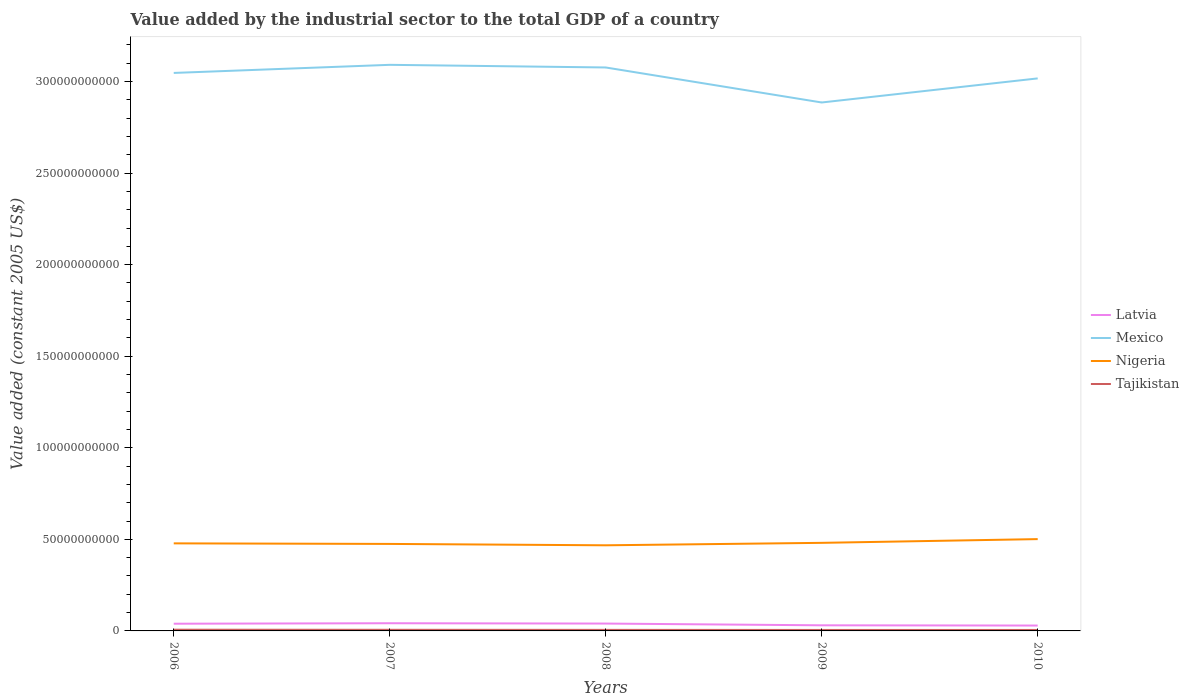Does the line corresponding to Latvia intersect with the line corresponding to Tajikistan?
Your answer should be very brief. No. Across all years, what is the maximum value added by the industrial sector in Mexico?
Your answer should be compact. 2.89e+11. What is the total value added by the industrial sector in Latvia in the graph?
Offer a terse response. 1.26e+08. What is the difference between the highest and the second highest value added by the industrial sector in Mexico?
Offer a terse response. 2.06e+1. Is the value added by the industrial sector in Nigeria strictly greater than the value added by the industrial sector in Mexico over the years?
Keep it short and to the point. Yes. How many years are there in the graph?
Ensure brevity in your answer.  5. Are the values on the major ticks of Y-axis written in scientific E-notation?
Give a very brief answer. No. Does the graph contain any zero values?
Ensure brevity in your answer.  No. Does the graph contain grids?
Make the answer very short. No. Where does the legend appear in the graph?
Your answer should be very brief. Center right. How many legend labels are there?
Give a very brief answer. 4. How are the legend labels stacked?
Your answer should be compact. Vertical. What is the title of the graph?
Your answer should be very brief. Value added by the industrial sector to the total GDP of a country. Does "Malta" appear as one of the legend labels in the graph?
Give a very brief answer. No. What is the label or title of the Y-axis?
Keep it short and to the point. Value added (constant 2005 US$). What is the Value added (constant 2005 US$) in Latvia in 2006?
Your response must be concise. 3.93e+09. What is the Value added (constant 2005 US$) in Mexico in 2006?
Provide a short and direct response. 3.05e+11. What is the Value added (constant 2005 US$) of Nigeria in 2006?
Provide a succinct answer. 4.78e+1. What is the Value added (constant 2005 US$) in Tajikistan in 2006?
Ensure brevity in your answer.  6.67e+08. What is the Value added (constant 2005 US$) of Latvia in 2007?
Ensure brevity in your answer.  4.20e+09. What is the Value added (constant 2005 US$) of Mexico in 2007?
Offer a terse response. 3.09e+11. What is the Value added (constant 2005 US$) in Nigeria in 2007?
Make the answer very short. 4.75e+1. What is the Value added (constant 2005 US$) in Tajikistan in 2007?
Offer a very short reply. 6.16e+08. What is the Value added (constant 2005 US$) of Latvia in 2008?
Your answer should be compact. 4.01e+09. What is the Value added (constant 2005 US$) of Mexico in 2008?
Offer a terse response. 3.08e+11. What is the Value added (constant 2005 US$) of Nigeria in 2008?
Your answer should be compact. 4.68e+1. What is the Value added (constant 2005 US$) of Tajikistan in 2008?
Your answer should be very brief. 5.72e+08. What is the Value added (constant 2005 US$) in Latvia in 2009?
Ensure brevity in your answer.  3.06e+09. What is the Value added (constant 2005 US$) of Mexico in 2009?
Offer a terse response. 2.89e+11. What is the Value added (constant 2005 US$) in Nigeria in 2009?
Make the answer very short. 4.81e+1. What is the Value added (constant 2005 US$) in Tajikistan in 2009?
Make the answer very short. 5.31e+08. What is the Value added (constant 2005 US$) in Latvia in 2010?
Make the answer very short. 2.94e+09. What is the Value added (constant 2005 US$) of Mexico in 2010?
Offer a very short reply. 3.02e+11. What is the Value added (constant 2005 US$) of Nigeria in 2010?
Give a very brief answer. 5.01e+1. What is the Value added (constant 2005 US$) of Tajikistan in 2010?
Offer a terse response. 5.19e+08. Across all years, what is the maximum Value added (constant 2005 US$) in Latvia?
Make the answer very short. 4.20e+09. Across all years, what is the maximum Value added (constant 2005 US$) of Mexico?
Provide a succinct answer. 3.09e+11. Across all years, what is the maximum Value added (constant 2005 US$) in Nigeria?
Your answer should be very brief. 5.01e+1. Across all years, what is the maximum Value added (constant 2005 US$) in Tajikistan?
Your response must be concise. 6.67e+08. Across all years, what is the minimum Value added (constant 2005 US$) in Latvia?
Offer a terse response. 2.94e+09. Across all years, what is the minimum Value added (constant 2005 US$) in Mexico?
Your answer should be very brief. 2.89e+11. Across all years, what is the minimum Value added (constant 2005 US$) of Nigeria?
Your answer should be compact. 4.68e+1. Across all years, what is the minimum Value added (constant 2005 US$) in Tajikistan?
Give a very brief answer. 5.19e+08. What is the total Value added (constant 2005 US$) in Latvia in the graph?
Ensure brevity in your answer.  1.81e+1. What is the total Value added (constant 2005 US$) of Mexico in the graph?
Provide a succinct answer. 1.51e+12. What is the total Value added (constant 2005 US$) in Nigeria in the graph?
Ensure brevity in your answer.  2.40e+11. What is the total Value added (constant 2005 US$) in Tajikistan in the graph?
Provide a short and direct response. 2.91e+09. What is the difference between the Value added (constant 2005 US$) in Latvia in 2006 and that in 2007?
Give a very brief answer. -2.67e+08. What is the difference between the Value added (constant 2005 US$) of Mexico in 2006 and that in 2007?
Make the answer very short. -4.43e+09. What is the difference between the Value added (constant 2005 US$) in Nigeria in 2006 and that in 2007?
Ensure brevity in your answer.  3.00e+08. What is the difference between the Value added (constant 2005 US$) in Tajikistan in 2006 and that in 2007?
Offer a very short reply. 5.12e+07. What is the difference between the Value added (constant 2005 US$) of Latvia in 2006 and that in 2008?
Your response must be concise. -8.38e+07. What is the difference between the Value added (constant 2005 US$) of Mexico in 2006 and that in 2008?
Make the answer very short. -2.99e+09. What is the difference between the Value added (constant 2005 US$) in Nigeria in 2006 and that in 2008?
Offer a terse response. 1.05e+09. What is the difference between the Value added (constant 2005 US$) in Tajikistan in 2006 and that in 2008?
Give a very brief answer. 9.50e+07. What is the difference between the Value added (constant 2005 US$) of Latvia in 2006 and that in 2009?
Provide a short and direct response. 8.66e+08. What is the difference between the Value added (constant 2005 US$) in Mexico in 2006 and that in 2009?
Provide a short and direct response. 1.61e+1. What is the difference between the Value added (constant 2005 US$) in Nigeria in 2006 and that in 2009?
Your response must be concise. -2.82e+08. What is the difference between the Value added (constant 2005 US$) in Tajikistan in 2006 and that in 2009?
Provide a short and direct response. 1.36e+08. What is the difference between the Value added (constant 2005 US$) in Latvia in 2006 and that in 2010?
Keep it short and to the point. 9.92e+08. What is the difference between the Value added (constant 2005 US$) in Mexico in 2006 and that in 2010?
Your answer should be very brief. 2.98e+09. What is the difference between the Value added (constant 2005 US$) of Nigeria in 2006 and that in 2010?
Ensure brevity in your answer.  -2.32e+09. What is the difference between the Value added (constant 2005 US$) of Tajikistan in 2006 and that in 2010?
Provide a short and direct response. 1.48e+08. What is the difference between the Value added (constant 2005 US$) in Latvia in 2007 and that in 2008?
Offer a very short reply. 1.83e+08. What is the difference between the Value added (constant 2005 US$) in Mexico in 2007 and that in 2008?
Your answer should be very brief. 1.44e+09. What is the difference between the Value added (constant 2005 US$) of Nigeria in 2007 and that in 2008?
Keep it short and to the point. 7.52e+08. What is the difference between the Value added (constant 2005 US$) of Tajikistan in 2007 and that in 2008?
Offer a terse response. 4.39e+07. What is the difference between the Value added (constant 2005 US$) of Latvia in 2007 and that in 2009?
Your answer should be compact. 1.13e+09. What is the difference between the Value added (constant 2005 US$) of Mexico in 2007 and that in 2009?
Offer a very short reply. 2.06e+1. What is the difference between the Value added (constant 2005 US$) of Nigeria in 2007 and that in 2009?
Provide a succinct answer. -5.82e+08. What is the difference between the Value added (constant 2005 US$) in Tajikistan in 2007 and that in 2009?
Your answer should be compact. 8.45e+07. What is the difference between the Value added (constant 2005 US$) in Latvia in 2007 and that in 2010?
Provide a succinct answer. 1.26e+09. What is the difference between the Value added (constant 2005 US$) of Mexico in 2007 and that in 2010?
Offer a terse response. 7.41e+09. What is the difference between the Value added (constant 2005 US$) in Nigeria in 2007 and that in 2010?
Offer a very short reply. -2.62e+09. What is the difference between the Value added (constant 2005 US$) of Tajikistan in 2007 and that in 2010?
Make the answer very short. 9.73e+07. What is the difference between the Value added (constant 2005 US$) of Latvia in 2008 and that in 2009?
Offer a terse response. 9.50e+08. What is the difference between the Value added (constant 2005 US$) of Mexico in 2008 and that in 2009?
Offer a very short reply. 1.91e+1. What is the difference between the Value added (constant 2005 US$) in Nigeria in 2008 and that in 2009?
Your response must be concise. -1.33e+09. What is the difference between the Value added (constant 2005 US$) in Tajikistan in 2008 and that in 2009?
Provide a short and direct response. 4.07e+07. What is the difference between the Value added (constant 2005 US$) of Latvia in 2008 and that in 2010?
Ensure brevity in your answer.  1.08e+09. What is the difference between the Value added (constant 2005 US$) of Mexico in 2008 and that in 2010?
Your response must be concise. 5.96e+09. What is the difference between the Value added (constant 2005 US$) of Nigeria in 2008 and that in 2010?
Ensure brevity in your answer.  -3.37e+09. What is the difference between the Value added (constant 2005 US$) in Tajikistan in 2008 and that in 2010?
Make the answer very short. 5.35e+07. What is the difference between the Value added (constant 2005 US$) in Latvia in 2009 and that in 2010?
Offer a very short reply. 1.26e+08. What is the difference between the Value added (constant 2005 US$) of Mexico in 2009 and that in 2010?
Offer a terse response. -1.32e+1. What is the difference between the Value added (constant 2005 US$) in Nigeria in 2009 and that in 2010?
Offer a very short reply. -2.04e+09. What is the difference between the Value added (constant 2005 US$) in Tajikistan in 2009 and that in 2010?
Provide a short and direct response. 1.28e+07. What is the difference between the Value added (constant 2005 US$) of Latvia in 2006 and the Value added (constant 2005 US$) of Mexico in 2007?
Provide a short and direct response. -3.05e+11. What is the difference between the Value added (constant 2005 US$) in Latvia in 2006 and the Value added (constant 2005 US$) in Nigeria in 2007?
Offer a terse response. -4.36e+1. What is the difference between the Value added (constant 2005 US$) in Latvia in 2006 and the Value added (constant 2005 US$) in Tajikistan in 2007?
Keep it short and to the point. 3.31e+09. What is the difference between the Value added (constant 2005 US$) in Mexico in 2006 and the Value added (constant 2005 US$) in Nigeria in 2007?
Provide a short and direct response. 2.57e+11. What is the difference between the Value added (constant 2005 US$) of Mexico in 2006 and the Value added (constant 2005 US$) of Tajikistan in 2007?
Your response must be concise. 3.04e+11. What is the difference between the Value added (constant 2005 US$) of Nigeria in 2006 and the Value added (constant 2005 US$) of Tajikistan in 2007?
Offer a terse response. 4.72e+1. What is the difference between the Value added (constant 2005 US$) of Latvia in 2006 and the Value added (constant 2005 US$) of Mexico in 2008?
Keep it short and to the point. -3.04e+11. What is the difference between the Value added (constant 2005 US$) in Latvia in 2006 and the Value added (constant 2005 US$) in Nigeria in 2008?
Make the answer very short. -4.28e+1. What is the difference between the Value added (constant 2005 US$) of Latvia in 2006 and the Value added (constant 2005 US$) of Tajikistan in 2008?
Make the answer very short. 3.36e+09. What is the difference between the Value added (constant 2005 US$) in Mexico in 2006 and the Value added (constant 2005 US$) in Nigeria in 2008?
Make the answer very short. 2.58e+11. What is the difference between the Value added (constant 2005 US$) of Mexico in 2006 and the Value added (constant 2005 US$) of Tajikistan in 2008?
Provide a short and direct response. 3.04e+11. What is the difference between the Value added (constant 2005 US$) in Nigeria in 2006 and the Value added (constant 2005 US$) in Tajikistan in 2008?
Ensure brevity in your answer.  4.72e+1. What is the difference between the Value added (constant 2005 US$) of Latvia in 2006 and the Value added (constant 2005 US$) of Mexico in 2009?
Provide a succinct answer. -2.85e+11. What is the difference between the Value added (constant 2005 US$) of Latvia in 2006 and the Value added (constant 2005 US$) of Nigeria in 2009?
Your answer should be very brief. -4.42e+1. What is the difference between the Value added (constant 2005 US$) of Latvia in 2006 and the Value added (constant 2005 US$) of Tajikistan in 2009?
Make the answer very short. 3.40e+09. What is the difference between the Value added (constant 2005 US$) in Mexico in 2006 and the Value added (constant 2005 US$) in Nigeria in 2009?
Your response must be concise. 2.57e+11. What is the difference between the Value added (constant 2005 US$) of Mexico in 2006 and the Value added (constant 2005 US$) of Tajikistan in 2009?
Offer a very short reply. 3.04e+11. What is the difference between the Value added (constant 2005 US$) in Nigeria in 2006 and the Value added (constant 2005 US$) in Tajikistan in 2009?
Your answer should be compact. 4.73e+1. What is the difference between the Value added (constant 2005 US$) of Latvia in 2006 and the Value added (constant 2005 US$) of Mexico in 2010?
Offer a terse response. -2.98e+11. What is the difference between the Value added (constant 2005 US$) of Latvia in 2006 and the Value added (constant 2005 US$) of Nigeria in 2010?
Make the answer very short. -4.62e+1. What is the difference between the Value added (constant 2005 US$) of Latvia in 2006 and the Value added (constant 2005 US$) of Tajikistan in 2010?
Offer a terse response. 3.41e+09. What is the difference between the Value added (constant 2005 US$) in Mexico in 2006 and the Value added (constant 2005 US$) in Nigeria in 2010?
Give a very brief answer. 2.55e+11. What is the difference between the Value added (constant 2005 US$) of Mexico in 2006 and the Value added (constant 2005 US$) of Tajikistan in 2010?
Provide a succinct answer. 3.04e+11. What is the difference between the Value added (constant 2005 US$) in Nigeria in 2006 and the Value added (constant 2005 US$) in Tajikistan in 2010?
Offer a terse response. 4.73e+1. What is the difference between the Value added (constant 2005 US$) in Latvia in 2007 and the Value added (constant 2005 US$) in Mexico in 2008?
Offer a very short reply. -3.03e+11. What is the difference between the Value added (constant 2005 US$) of Latvia in 2007 and the Value added (constant 2005 US$) of Nigeria in 2008?
Your answer should be very brief. -4.26e+1. What is the difference between the Value added (constant 2005 US$) in Latvia in 2007 and the Value added (constant 2005 US$) in Tajikistan in 2008?
Make the answer very short. 3.63e+09. What is the difference between the Value added (constant 2005 US$) in Mexico in 2007 and the Value added (constant 2005 US$) in Nigeria in 2008?
Offer a very short reply. 2.62e+11. What is the difference between the Value added (constant 2005 US$) of Mexico in 2007 and the Value added (constant 2005 US$) of Tajikistan in 2008?
Your answer should be very brief. 3.09e+11. What is the difference between the Value added (constant 2005 US$) of Nigeria in 2007 and the Value added (constant 2005 US$) of Tajikistan in 2008?
Offer a very short reply. 4.69e+1. What is the difference between the Value added (constant 2005 US$) in Latvia in 2007 and the Value added (constant 2005 US$) in Mexico in 2009?
Your answer should be compact. -2.84e+11. What is the difference between the Value added (constant 2005 US$) in Latvia in 2007 and the Value added (constant 2005 US$) in Nigeria in 2009?
Give a very brief answer. -4.39e+1. What is the difference between the Value added (constant 2005 US$) in Latvia in 2007 and the Value added (constant 2005 US$) in Tajikistan in 2009?
Make the answer very short. 3.67e+09. What is the difference between the Value added (constant 2005 US$) of Mexico in 2007 and the Value added (constant 2005 US$) of Nigeria in 2009?
Offer a terse response. 2.61e+11. What is the difference between the Value added (constant 2005 US$) in Mexico in 2007 and the Value added (constant 2005 US$) in Tajikistan in 2009?
Offer a terse response. 3.09e+11. What is the difference between the Value added (constant 2005 US$) in Nigeria in 2007 and the Value added (constant 2005 US$) in Tajikistan in 2009?
Offer a very short reply. 4.70e+1. What is the difference between the Value added (constant 2005 US$) of Latvia in 2007 and the Value added (constant 2005 US$) of Mexico in 2010?
Ensure brevity in your answer.  -2.97e+11. What is the difference between the Value added (constant 2005 US$) of Latvia in 2007 and the Value added (constant 2005 US$) of Nigeria in 2010?
Your answer should be compact. -4.59e+1. What is the difference between the Value added (constant 2005 US$) of Latvia in 2007 and the Value added (constant 2005 US$) of Tajikistan in 2010?
Give a very brief answer. 3.68e+09. What is the difference between the Value added (constant 2005 US$) in Mexico in 2007 and the Value added (constant 2005 US$) in Nigeria in 2010?
Make the answer very short. 2.59e+11. What is the difference between the Value added (constant 2005 US$) of Mexico in 2007 and the Value added (constant 2005 US$) of Tajikistan in 2010?
Keep it short and to the point. 3.09e+11. What is the difference between the Value added (constant 2005 US$) in Nigeria in 2007 and the Value added (constant 2005 US$) in Tajikistan in 2010?
Keep it short and to the point. 4.70e+1. What is the difference between the Value added (constant 2005 US$) of Latvia in 2008 and the Value added (constant 2005 US$) of Mexico in 2009?
Your answer should be compact. -2.85e+11. What is the difference between the Value added (constant 2005 US$) in Latvia in 2008 and the Value added (constant 2005 US$) in Nigeria in 2009?
Your response must be concise. -4.41e+1. What is the difference between the Value added (constant 2005 US$) in Latvia in 2008 and the Value added (constant 2005 US$) in Tajikistan in 2009?
Give a very brief answer. 3.48e+09. What is the difference between the Value added (constant 2005 US$) of Mexico in 2008 and the Value added (constant 2005 US$) of Nigeria in 2009?
Offer a very short reply. 2.60e+11. What is the difference between the Value added (constant 2005 US$) in Mexico in 2008 and the Value added (constant 2005 US$) in Tajikistan in 2009?
Give a very brief answer. 3.07e+11. What is the difference between the Value added (constant 2005 US$) in Nigeria in 2008 and the Value added (constant 2005 US$) in Tajikistan in 2009?
Offer a terse response. 4.62e+1. What is the difference between the Value added (constant 2005 US$) in Latvia in 2008 and the Value added (constant 2005 US$) in Mexico in 2010?
Give a very brief answer. -2.98e+11. What is the difference between the Value added (constant 2005 US$) of Latvia in 2008 and the Value added (constant 2005 US$) of Nigeria in 2010?
Provide a succinct answer. -4.61e+1. What is the difference between the Value added (constant 2005 US$) in Latvia in 2008 and the Value added (constant 2005 US$) in Tajikistan in 2010?
Provide a short and direct response. 3.50e+09. What is the difference between the Value added (constant 2005 US$) in Mexico in 2008 and the Value added (constant 2005 US$) in Nigeria in 2010?
Make the answer very short. 2.58e+11. What is the difference between the Value added (constant 2005 US$) of Mexico in 2008 and the Value added (constant 2005 US$) of Tajikistan in 2010?
Provide a short and direct response. 3.07e+11. What is the difference between the Value added (constant 2005 US$) of Nigeria in 2008 and the Value added (constant 2005 US$) of Tajikistan in 2010?
Give a very brief answer. 4.62e+1. What is the difference between the Value added (constant 2005 US$) in Latvia in 2009 and the Value added (constant 2005 US$) in Mexico in 2010?
Your response must be concise. -2.99e+11. What is the difference between the Value added (constant 2005 US$) in Latvia in 2009 and the Value added (constant 2005 US$) in Nigeria in 2010?
Give a very brief answer. -4.71e+1. What is the difference between the Value added (constant 2005 US$) of Latvia in 2009 and the Value added (constant 2005 US$) of Tajikistan in 2010?
Your answer should be very brief. 2.55e+09. What is the difference between the Value added (constant 2005 US$) in Mexico in 2009 and the Value added (constant 2005 US$) in Nigeria in 2010?
Your answer should be very brief. 2.38e+11. What is the difference between the Value added (constant 2005 US$) in Mexico in 2009 and the Value added (constant 2005 US$) in Tajikistan in 2010?
Offer a terse response. 2.88e+11. What is the difference between the Value added (constant 2005 US$) of Nigeria in 2009 and the Value added (constant 2005 US$) of Tajikistan in 2010?
Make the answer very short. 4.76e+1. What is the average Value added (constant 2005 US$) of Latvia per year?
Provide a short and direct response. 3.63e+09. What is the average Value added (constant 2005 US$) of Mexico per year?
Offer a terse response. 3.02e+11. What is the average Value added (constant 2005 US$) in Nigeria per year?
Give a very brief answer. 4.81e+1. What is the average Value added (constant 2005 US$) of Tajikistan per year?
Your answer should be very brief. 5.81e+08. In the year 2006, what is the difference between the Value added (constant 2005 US$) of Latvia and Value added (constant 2005 US$) of Mexico?
Give a very brief answer. -3.01e+11. In the year 2006, what is the difference between the Value added (constant 2005 US$) in Latvia and Value added (constant 2005 US$) in Nigeria?
Give a very brief answer. -4.39e+1. In the year 2006, what is the difference between the Value added (constant 2005 US$) of Latvia and Value added (constant 2005 US$) of Tajikistan?
Ensure brevity in your answer.  3.26e+09. In the year 2006, what is the difference between the Value added (constant 2005 US$) in Mexico and Value added (constant 2005 US$) in Nigeria?
Offer a very short reply. 2.57e+11. In the year 2006, what is the difference between the Value added (constant 2005 US$) in Mexico and Value added (constant 2005 US$) in Tajikistan?
Give a very brief answer. 3.04e+11. In the year 2006, what is the difference between the Value added (constant 2005 US$) of Nigeria and Value added (constant 2005 US$) of Tajikistan?
Provide a succinct answer. 4.71e+1. In the year 2007, what is the difference between the Value added (constant 2005 US$) in Latvia and Value added (constant 2005 US$) in Mexico?
Ensure brevity in your answer.  -3.05e+11. In the year 2007, what is the difference between the Value added (constant 2005 US$) of Latvia and Value added (constant 2005 US$) of Nigeria?
Offer a terse response. -4.33e+1. In the year 2007, what is the difference between the Value added (constant 2005 US$) of Latvia and Value added (constant 2005 US$) of Tajikistan?
Give a very brief answer. 3.58e+09. In the year 2007, what is the difference between the Value added (constant 2005 US$) in Mexico and Value added (constant 2005 US$) in Nigeria?
Your answer should be compact. 2.62e+11. In the year 2007, what is the difference between the Value added (constant 2005 US$) in Mexico and Value added (constant 2005 US$) in Tajikistan?
Your answer should be compact. 3.08e+11. In the year 2007, what is the difference between the Value added (constant 2005 US$) of Nigeria and Value added (constant 2005 US$) of Tajikistan?
Ensure brevity in your answer.  4.69e+1. In the year 2008, what is the difference between the Value added (constant 2005 US$) in Latvia and Value added (constant 2005 US$) in Mexico?
Your response must be concise. -3.04e+11. In the year 2008, what is the difference between the Value added (constant 2005 US$) in Latvia and Value added (constant 2005 US$) in Nigeria?
Provide a short and direct response. -4.27e+1. In the year 2008, what is the difference between the Value added (constant 2005 US$) of Latvia and Value added (constant 2005 US$) of Tajikistan?
Give a very brief answer. 3.44e+09. In the year 2008, what is the difference between the Value added (constant 2005 US$) of Mexico and Value added (constant 2005 US$) of Nigeria?
Your response must be concise. 2.61e+11. In the year 2008, what is the difference between the Value added (constant 2005 US$) of Mexico and Value added (constant 2005 US$) of Tajikistan?
Offer a terse response. 3.07e+11. In the year 2008, what is the difference between the Value added (constant 2005 US$) in Nigeria and Value added (constant 2005 US$) in Tajikistan?
Provide a succinct answer. 4.62e+1. In the year 2009, what is the difference between the Value added (constant 2005 US$) of Latvia and Value added (constant 2005 US$) of Mexico?
Your answer should be compact. -2.85e+11. In the year 2009, what is the difference between the Value added (constant 2005 US$) of Latvia and Value added (constant 2005 US$) of Nigeria?
Provide a succinct answer. -4.50e+1. In the year 2009, what is the difference between the Value added (constant 2005 US$) in Latvia and Value added (constant 2005 US$) in Tajikistan?
Give a very brief answer. 2.53e+09. In the year 2009, what is the difference between the Value added (constant 2005 US$) in Mexico and Value added (constant 2005 US$) in Nigeria?
Offer a terse response. 2.40e+11. In the year 2009, what is the difference between the Value added (constant 2005 US$) in Mexico and Value added (constant 2005 US$) in Tajikistan?
Provide a short and direct response. 2.88e+11. In the year 2009, what is the difference between the Value added (constant 2005 US$) in Nigeria and Value added (constant 2005 US$) in Tajikistan?
Give a very brief answer. 4.76e+1. In the year 2010, what is the difference between the Value added (constant 2005 US$) of Latvia and Value added (constant 2005 US$) of Mexico?
Your response must be concise. -2.99e+11. In the year 2010, what is the difference between the Value added (constant 2005 US$) of Latvia and Value added (constant 2005 US$) of Nigeria?
Provide a succinct answer. -4.72e+1. In the year 2010, what is the difference between the Value added (constant 2005 US$) in Latvia and Value added (constant 2005 US$) in Tajikistan?
Provide a short and direct response. 2.42e+09. In the year 2010, what is the difference between the Value added (constant 2005 US$) of Mexico and Value added (constant 2005 US$) of Nigeria?
Provide a short and direct response. 2.52e+11. In the year 2010, what is the difference between the Value added (constant 2005 US$) in Mexico and Value added (constant 2005 US$) in Tajikistan?
Provide a succinct answer. 3.01e+11. In the year 2010, what is the difference between the Value added (constant 2005 US$) of Nigeria and Value added (constant 2005 US$) of Tajikistan?
Ensure brevity in your answer.  4.96e+1. What is the ratio of the Value added (constant 2005 US$) in Latvia in 2006 to that in 2007?
Offer a terse response. 0.94. What is the ratio of the Value added (constant 2005 US$) of Mexico in 2006 to that in 2007?
Your answer should be compact. 0.99. What is the ratio of the Value added (constant 2005 US$) in Nigeria in 2006 to that in 2007?
Keep it short and to the point. 1.01. What is the ratio of the Value added (constant 2005 US$) in Tajikistan in 2006 to that in 2007?
Provide a short and direct response. 1.08. What is the ratio of the Value added (constant 2005 US$) in Latvia in 2006 to that in 2008?
Your response must be concise. 0.98. What is the ratio of the Value added (constant 2005 US$) of Mexico in 2006 to that in 2008?
Your response must be concise. 0.99. What is the ratio of the Value added (constant 2005 US$) in Nigeria in 2006 to that in 2008?
Your answer should be compact. 1.02. What is the ratio of the Value added (constant 2005 US$) in Tajikistan in 2006 to that in 2008?
Provide a short and direct response. 1.17. What is the ratio of the Value added (constant 2005 US$) of Latvia in 2006 to that in 2009?
Offer a terse response. 1.28. What is the ratio of the Value added (constant 2005 US$) in Mexico in 2006 to that in 2009?
Your answer should be compact. 1.06. What is the ratio of the Value added (constant 2005 US$) of Nigeria in 2006 to that in 2009?
Ensure brevity in your answer.  0.99. What is the ratio of the Value added (constant 2005 US$) in Tajikistan in 2006 to that in 2009?
Keep it short and to the point. 1.26. What is the ratio of the Value added (constant 2005 US$) in Latvia in 2006 to that in 2010?
Offer a very short reply. 1.34. What is the ratio of the Value added (constant 2005 US$) in Mexico in 2006 to that in 2010?
Offer a very short reply. 1.01. What is the ratio of the Value added (constant 2005 US$) in Nigeria in 2006 to that in 2010?
Give a very brief answer. 0.95. What is the ratio of the Value added (constant 2005 US$) of Tajikistan in 2006 to that in 2010?
Provide a succinct answer. 1.29. What is the ratio of the Value added (constant 2005 US$) in Latvia in 2007 to that in 2008?
Your response must be concise. 1.05. What is the ratio of the Value added (constant 2005 US$) of Nigeria in 2007 to that in 2008?
Provide a succinct answer. 1.02. What is the ratio of the Value added (constant 2005 US$) in Tajikistan in 2007 to that in 2008?
Your answer should be compact. 1.08. What is the ratio of the Value added (constant 2005 US$) in Latvia in 2007 to that in 2009?
Provide a short and direct response. 1.37. What is the ratio of the Value added (constant 2005 US$) in Mexico in 2007 to that in 2009?
Give a very brief answer. 1.07. What is the ratio of the Value added (constant 2005 US$) in Nigeria in 2007 to that in 2009?
Make the answer very short. 0.99. What is the ratio of the Value added (constant 2005 US$) in Tajikistan in 2007 to that in 2009?
Give a very brief answer. 1.16. What is the ratio of the Value added (constant 2005 US$) in Latvia in 2007 to that in 2010?
Your answer should be compact. 1.43. What is the ratio of the Value added (constant 2005 US$) in Mexico in 2007 to that in 2010?
Your answer should be very brief. 1.02. What is the ratio of the Value added (constant 2005 US$) of Nigeria in 2007 to that in 2010?
Ensure brevity in your answer.  0.95. What is the ratio of the Value added (constant 2005 US$) in Tajikistan in 2007 to that in 2010?
Make the answer very short. 1.19. What is the ratio of the Value added (constant 2005 US$) in Latvia in 2008 to that in 2009?
Offer a very short reply. 1.31. What is the ratio of the Value added (constant 2005 US$) in Mexico in 2008 to that in 2009?
Ensure brevity in your answer.  1.07. What is the ratio of the Value added (constant 2005 US$) of Nigeria in 2008 to that in 2009?
Your answer should be very brief. 0.97. What is the ratio of the Value added (constant 2005 US$) of Tajikistan in 2008 to that in 2009?
Ensure brevity in your answer.  1.08. What is the ratio of the Value added (constant 2005 US$) of Latvia in 2008 to that in 2010?
Provide a short and direct response. 1.37. What is the ratio of the Value added (constant 2005 US$) of Mexico in 2008 to that in 2010?
Your answer should be compact. 1.02. What is the ratio of the Value added (constant 2005 US$) of Nigeria in 2008 to that in 2010?
Your response must be concise. 0.93. What is the ratio of the Value added (constant 2005 US$) in Tajikistan in 2008 to that in 2010?
Offer a terse response. 1.1. What is the ratio of the Value added (constant 2005 US$) in Latvia in 2009 to that in 2010?
Make the answer very short. 1.04. What is the ratio of the Value added (constant 2005 US$) of Mexico in 2009 to that in 2010?
Your answer should be compact. 0.96. What is the ratio of the Value added (constant 2005 US$) of Nigeria in 2009 to that in 2010?
Your answer should be compact. 0.96. What is the ratio of the Value added (constant 2005 US$) of Tajikistan in 2009 to that in 2010?
Offer a terse response. 1.02. What is the difference between the highest and the second highest Value added (constant 2005 US$) in Latvia?
Make the answer very short. 1.83e+08. What is the difference between the highest and the second highest Value added (constant 2005 US$) in Mexico?
Your answer should be very brief. 1.44e+09. What is the difference between the highest and the second highest Value added (constant 2005 US$) of Nigeria?
Keep it short and to the point. 2.04e+09. What is the difference between the highest and the second highest Value added (constant 2005 US$) in Tajikistan?
Make the answer very short. 5.12e+07. What is the difference between the highest and the lowest Value added (constant 2005 US$) in Latvia?
Keep it short and to the point. 1.26e+09. What is the difference between the highest and the lowest Value added (constant 2005 US$) in Mexico?
Keep it short and to the point. 2.06e+1. What is the difference between the highest and the lowest Value added (constant 2005 US$) in Nigeria?
Provide a short and direct response. 3.37e+09. What is the difference between the highest and the lowest Value added (constant 2005 US$) of Tajikistan?
Make the answer very short. 1.48e+08. 